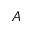<formula> <loc_0><loc_0><loc_500><loc_500>A</formula> 